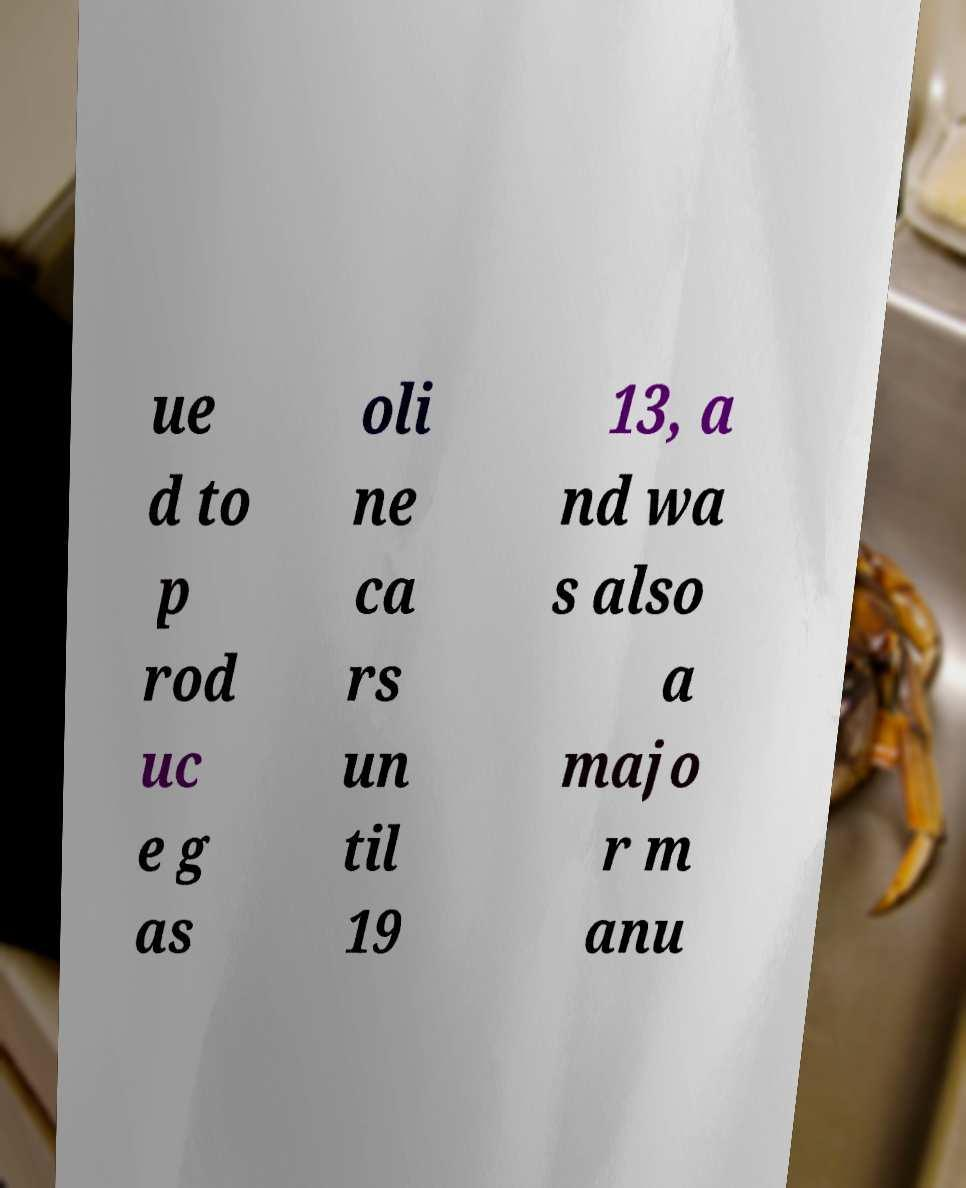For documentation purposes, I need the text within this image transcribed. Could you provide that? ue d to p rod uc e g as oli ne ca rs un til 19 13, a nd wa s also a majo r m anu 